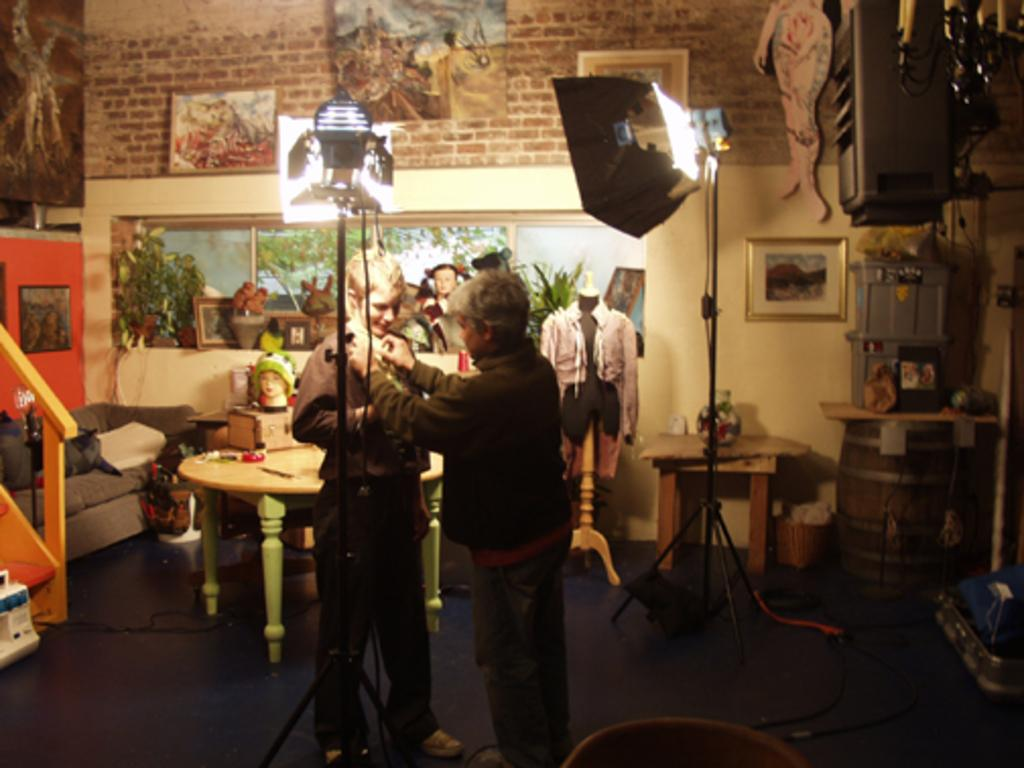How many people are present in the image? There are two people standing in the image. What can be seen on the wall in the image? There are photo frames on the wall. What piece of furniture is visible in the image? There is a table in the image. What type of seating is present in the image? There is a sofa set in the image. How many light sources are visible in the image? There are two lights in the image. What type of treatment is being administered to the people in the image? There is no indication of any treatment being administered to the people in the image. What is the purpose of the protest in the image? There is no protest present in the image. 